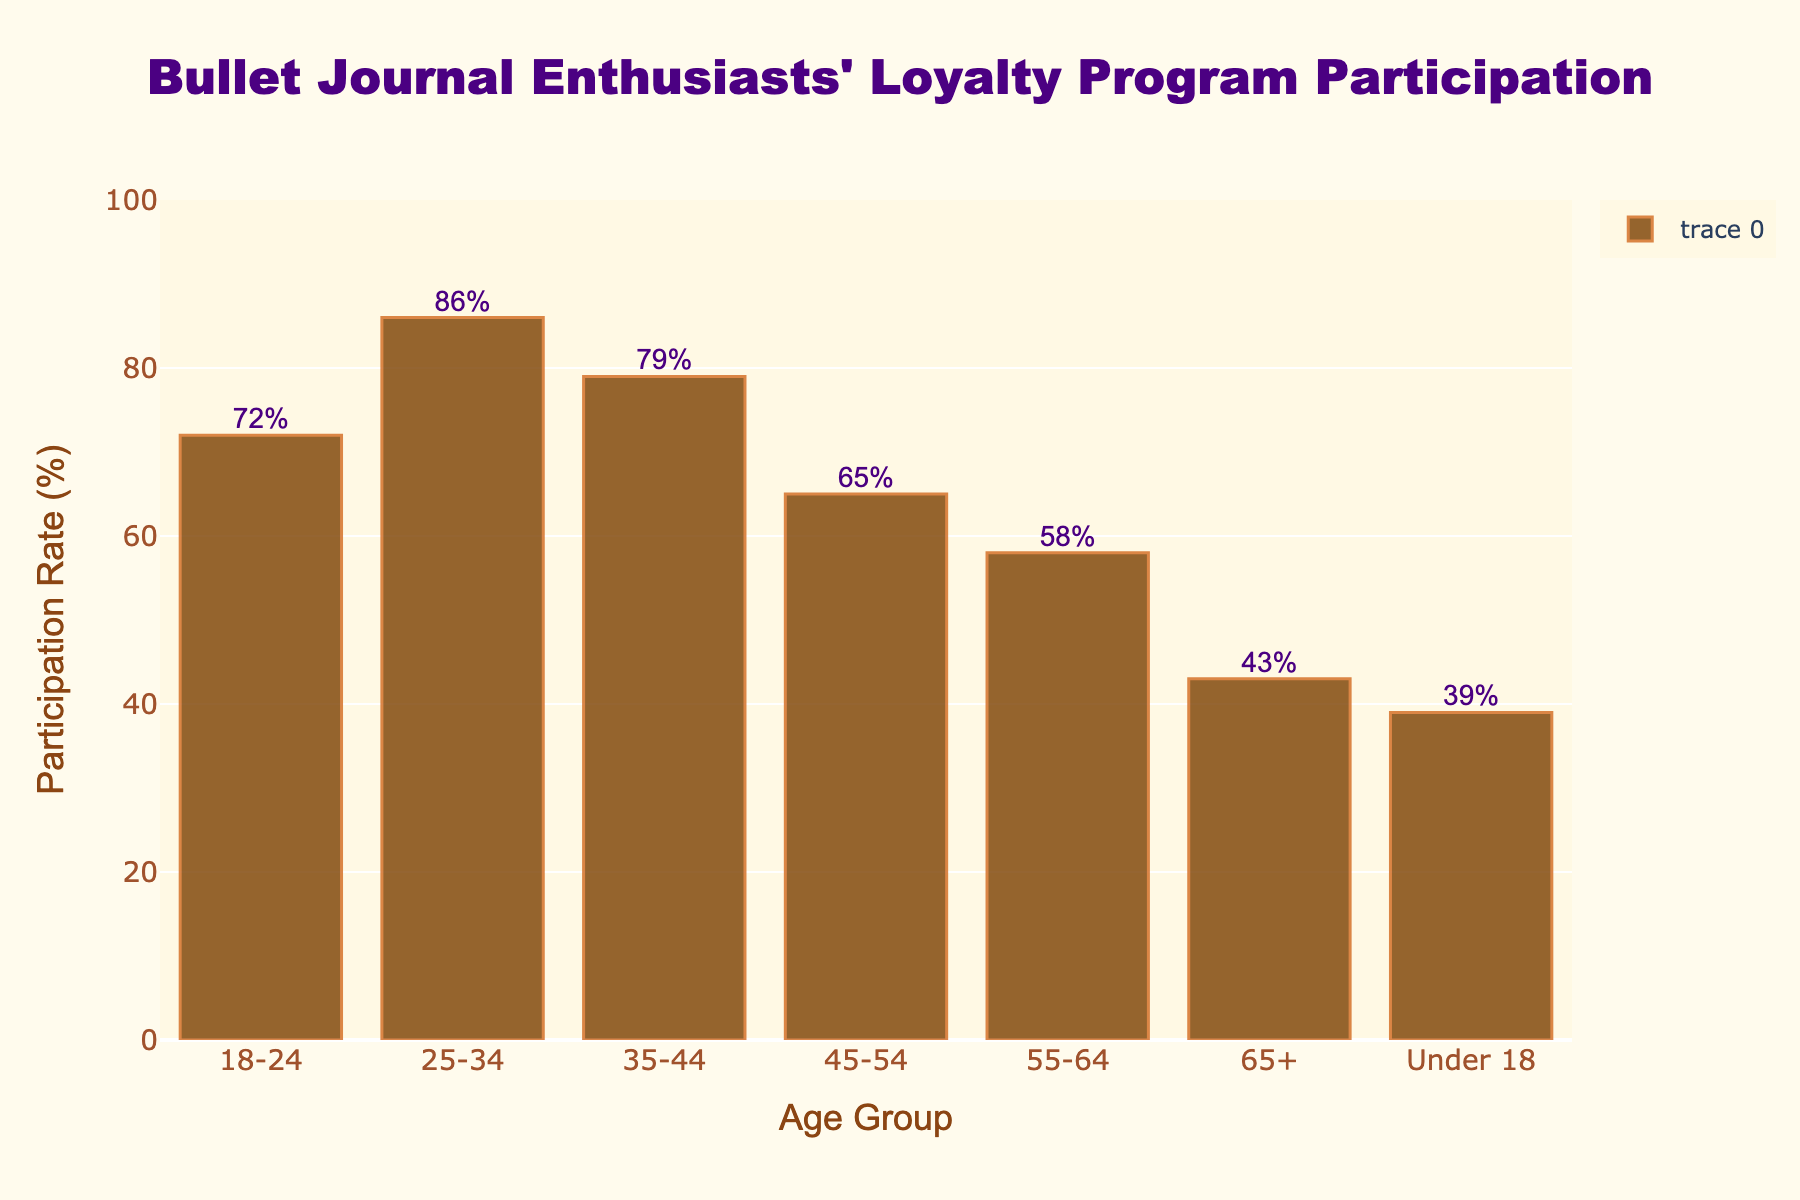what's the participation rate for the 25-34 age group? The figure shows participation rates for different age groups. Locate the 25-34 age group on the x-axis and check their corresponding value on the y-axis, which is 86%.
Answer: 86% which age group has the lowest participation rate? To find the lowest participation rate, compare the y-axis values for each age group. The lowest value is for the 'Under 18' age group with 39%.
Answer: Under 18 what is the difference in participation rates between the 35-44 and 55-64 age groups? Identify the participation rates for both age groups: 35-44 (79%) and 55-64 (58%). Subtract the lower rate from the higher: 79% - 58% = 21%.
Answer: 21% which age group shows a higher participation rate: 45-54 or 65+? Compare the y-axis values for the 45-54 age group (65%) and the 65+ age group (43%). The 45-54 age group has a higher rate.
Answer: 45-54 what is the sum of participation rates for the 18-24 and under 18 age groups? Find the participation rates for both groups: 18-24 (72%) and Under 18 (39%). Add them together: 72% + 39% = 111%.
Answer: 111% how many age groups have participation rates above 60%? Count the bars that reach above the 60% mark on the y-axis. The groups are 18-24 (72%), 25-34 (86%), 35-44 (79%), and 45-54 (65%), making a total of 4 age groups.
Answer: 4 what is the average participation rate for age groups 18-24, 25-34, and 35-44? Find the participation rates for these groups: 18-24 (72%), 25-34 (86%), and 35-44 (79%). Sum them up and divide by 3: (72 + 86 + 79) / 3 = 79%.
Answer: 79% which age group has the second-highest participation rate? First, find the highest rate, which is 25-34 (86%). Then, among the remaining groups, find the highest rate, which is 35-44 (79%).
Answer: 35-44 is there a noticeable decline in participation rates as the age groups get older? Observe the bars from the left (younger age groups) to the right (older age groups). The bars generally decline in height, showing lower participation rates as age increases, especially after 35-44.
Answer: Yes what is the median value of the participation rates? Sort the participation rates: 39%, 43%, 58%, 65%, 72%, 79%, 86%. The median is the middle value, which is 65%.
Answer: 65% 